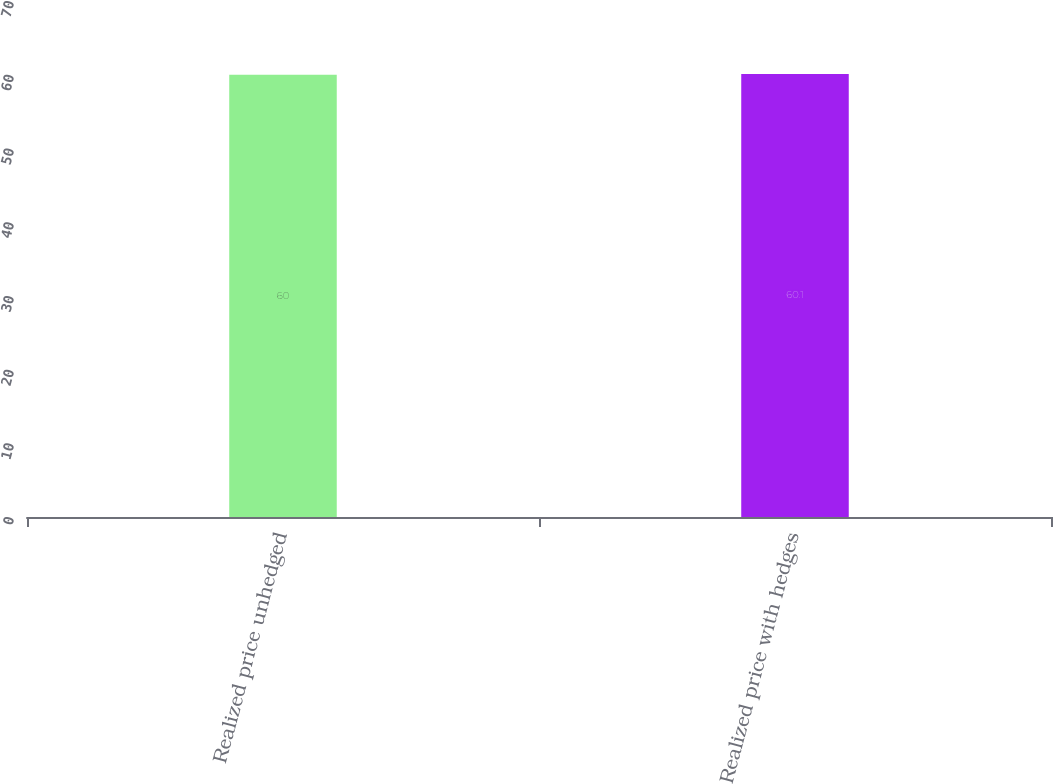Convert chart to OTSL. <chart><loc_0><loc_0><loc_500><loc_500><bar_chart><fcel>Realized price unhedged<fcel>Realized price with hedges<nl><fcel>60<fcel>60.1<nl></chart> 